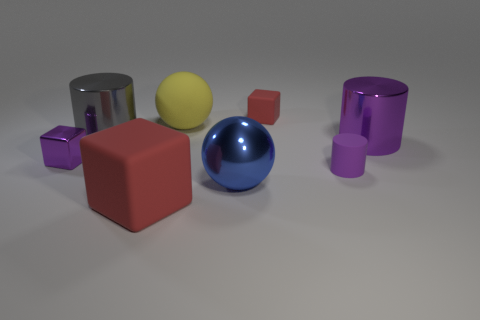What is the shape of the large shiny object that is the same color as the small metallic object?
Offer a very short reply. Cylinder. There is a large rubber object behind the small purple cube; what is its color?
Make the answer very short. Yellow. The purple cylinder that is the same material as the purple cube is what size?
Give a very brief answer. Large. There is a yellow object; is its size the same as the matte block behind the small purple rubber object?
Make the answer very short. No. There is a small cube to the left of the small red rubber block; what is it made of?
Make the answer very short. Metal. There is a red object behind the large gray cylinder; how many big metallic objects are left of it?
Provide a succinct answer. 2. Is there a big blue shiny object of the same shape as the small red matte object?
Offer a very short reply. No. There is a yellow rubber thing to the right of the big red block; is its size the same as the sphere in front of the small purple matte thing?
Your answer should be very brief. Yes. What is the shape of the purple thing that is in front of the small cube that is left of the blue object?
Make the answer very short. Cylinder. What number of other rubber cylinders have the same size as the matte cylinder?
Ensure brevity in your answer.  0. 